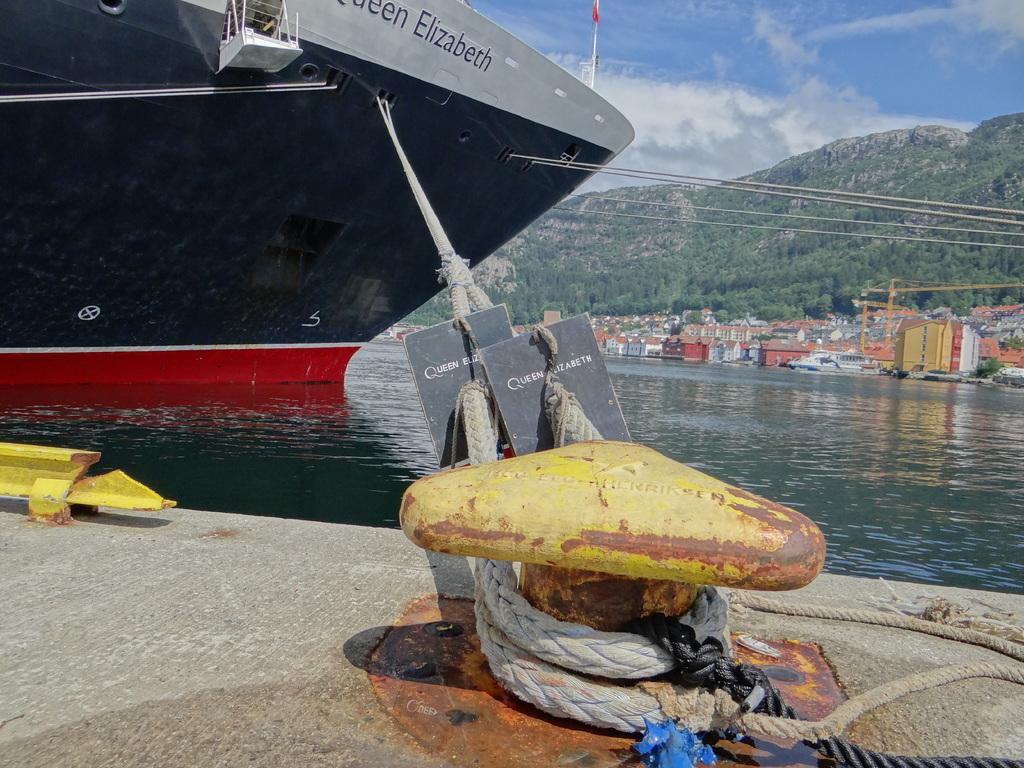What is the main subject of the image? The main subject of the image is a ship. How is the ship positioned in the image? The ship is hanged to a hook by a rope. What can be seen in the background of the image? In the background of the image, there are flags, the sky with clouds, hills, trees, buildings, and construction cranes. There is also water present. Can you see a bear holding a heart in the image? No, there is no bear or heart present in the image. 